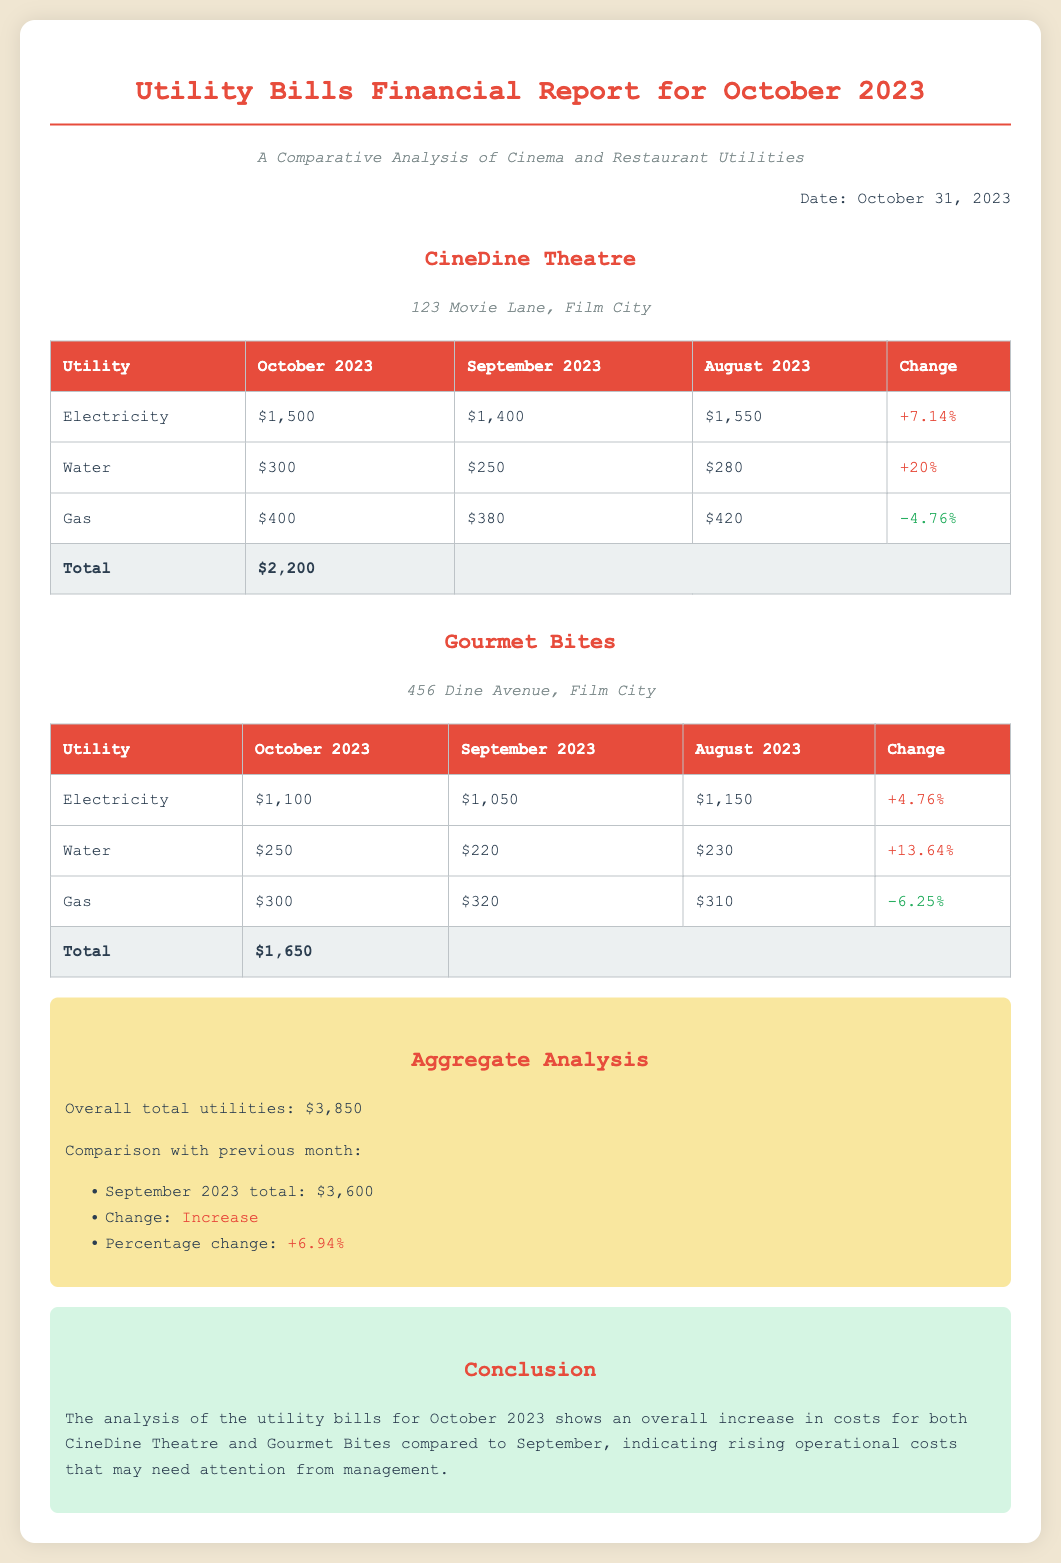What is the total utility cost for CineDine Theatre in October 2023? The total utility cost for CineDine Theatre is listed at the bottom of the table, which shows $2,200.
Answer: $2,200 What was the percentage increase in water charges for Gourmet Bites from September 2023 to October 2023? The percentage increase in water charges for Gourmet Bites is calculated from the change in the table, showing +13.64%.
Answer: +13.64% Which utility had the highest charge for CineDine Theatre in October 2023? The electricity charge for CineDine Theatre in October 2023 is the highest at $1,500 among all utilities listed.
Answer: Electricity What was the total utility cost for Gourmet Bites in September 2023? The total for Gourmet Bites is not listed explicitly but can be calculated from the individual utilities, or found directly in the document text. It is $1,650.
Answer: $1,650 What was the overall percentage change in total utilities from September 2023 to October 2023? The overall percentage change is derived from the comparison section, indicating a +6.94% increase.
Answer: +6.94% What is the location of CineDine Theatre? The location of CineDine Theatre is mentioned in a subtitle, which specifies 123 Movie Lane, Film City.
Answer: 123 Movie Lane, Film City What was the gas charge for the Cinema in October 2023? The gas charge for CineDine Theatre in October 2023 is provided in the respective row of the table, which indicates $400.
Answer: $400 What is the date of the report? The report explicitly states the date at the top right corner, which is October 31, 2023.
Answer: October 31, 2023 What was the gas charge for the Restaurant in September 2023? The gas charge for Gourmet Bites in September 2023 can be found in the table, listed as $320.
Answer: $320 